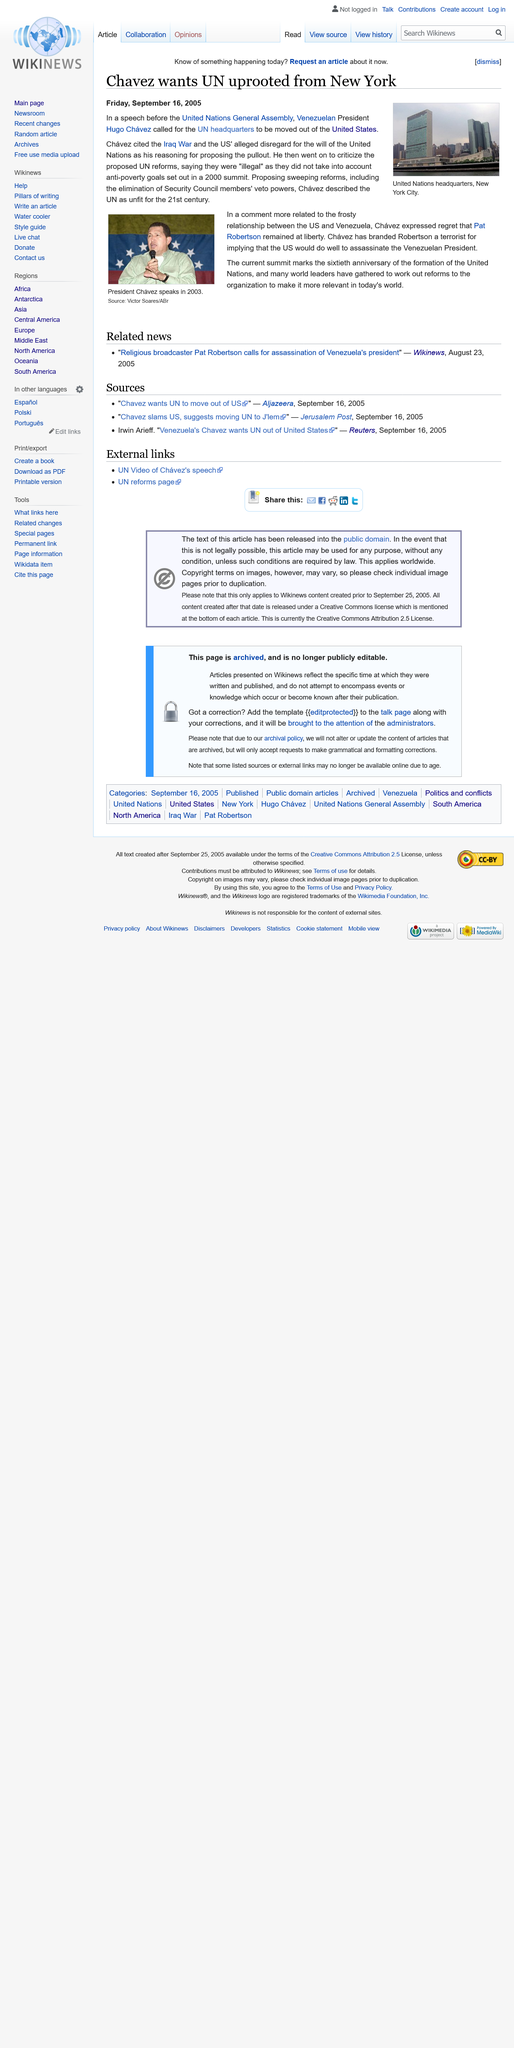List a handful of essential elements in this visual. President Hugo Chavez is pictured in front of the Venezuelan flag in the image. Chavez moved the UN Headquarters from New York because of the Iraq War and the US' disregard for the will of the United Nations. The buildings pictured are located in New York City, and the question is where they are located. 